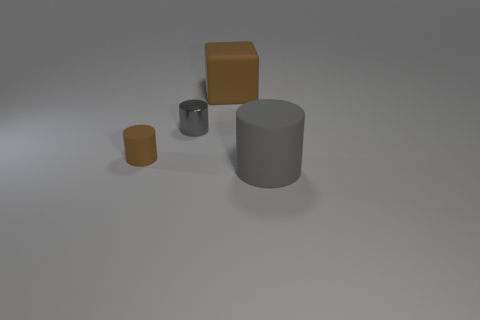Add 1 small shiny cylinders. How many objects exist? 5 Subtract all matte cylinders. How many cylinders are left? 1 Subtract all cylinders. How many objects are left? 1 Subtract all purple cylinders. Subtract all cyan cubes. How many cylinders are left? 3 Subtract all cyan metal things. Subtract all big matte cylinders. How many objects are left? 3 Add 1 tiny gray metallic things. How many tiny gray metallic things are left? 2 Add 2 matte cylinders. How many matte cylinders exist? 4 Subtract 1 brown blocks. How many objects are left? 3 